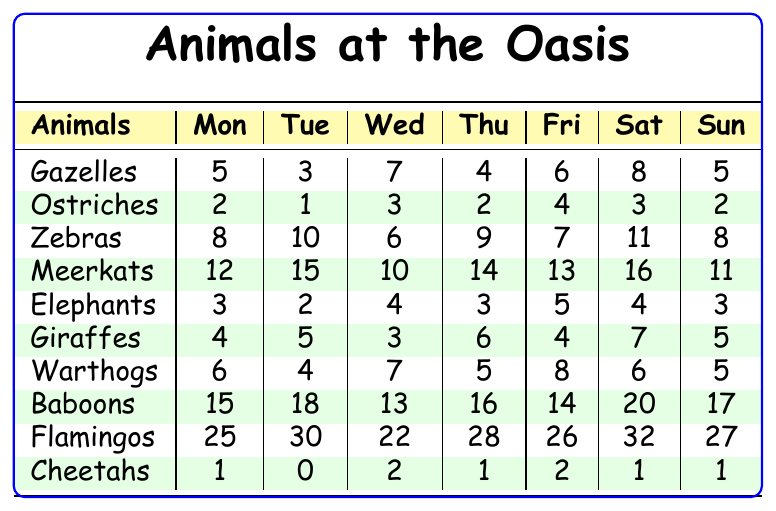What day did the most flamingos visit the oasis? The table shows the number of flamingos for each day. The highest number is 32 on Saturday.
Answer: Saturday How many meerkats were spotted on Wednesday? The table lists 10 meerkats seen on Wednesday.
Answer: 10 On which day were the most zebras spotted? Looking at the zebra counts, the maximum is 11 on Saturday.
Answer: Saturday What is the total number of baboons seen from Monday to Friday? Adding the baboons: 15 (Mon) + 18 (Tue) + 13 (Wed) + 16 (Thu) + 14 (Fri) = 76.
Answer: 76 Is there a day when the number of elephants spotted was greater than 4? The elephant counts are 3, 2, 4, 3, 5, 4, 3 respectively, and 5 on Friday is greater than 4.
Answer: Yes What is the average number of ostriches spotted over the week? To find the average, sum the numbers: 2 + 1 + 3 + 2 + 4 + 3 + 2 = 17. Divide by 7 gives approximately 2.43.
Answer: 2.43 Which animal had the least sightings on Tuesday? Comparing all numbers on Tuesday, ostriches had the least with 1.
Answer: Ostriches How many animals were spotted in total on Saturday? Calculate the total for Saturday: 8 (Gazelles) + 3 (Ostriches) + 11 (Zebras) + 16 (Meerkats) + 4 (Elephants) + 7 (Giraffes) + 6 (Warthogs) + 20 (Baboons) + 32 (Flamingos) + 1 (Cheetahs) = 108.
Answer: 108 On which day did the least number of cheetahs visit the oasis? The count for cheetahs shows 0 on Tuesday, which is the least.
Answer: Tuesday What is the difference in the number of giraffes spotted on Thursday and Friday? Giraffes on Thursday are 6 and on Friday are 4. The difference is 6 - 4 = 2.
Answer: 2 